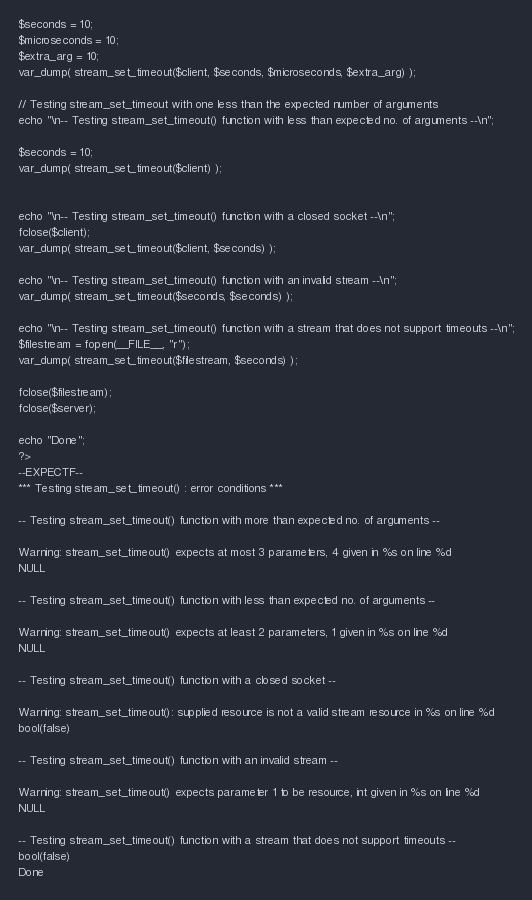<code> <loc_0><loc_0><loc_500><loc_500><_PHP_>
$seconds = 10;
$microseconds = 10;
$extra_arg = 10;
var_dump( stream_set_timeout($client, $seconds, $microseconds, $extra_arg) );

// Testing stream_set_timeout with one less than the expected number of arguments
echo "\n-- Testing stream_set_timeout() function with less than expected no. of arguments --\n";

$seconds = 10;
var_dump( stream_set_timeout($client) );


echo "\n-- Testing stream_set_timeout() function with a closed socket --\n";
fclose($client);
var_dump( stream_set_timeout($client, $seconds) );

echo "\n-- Testing stream_set_timeout() function with an invalid stream --\n";
var_dump( stream_set_timeout($seconds, $seconds) );

echo "\n-- Testing stream_set_timeout() function with a stream that does not support timeouts --\n";
$filestream = fopen(__FILE__, "r");
var_dump( stream_set_timeout($filestream, $seconds) );

fclose($filestream);
fclose($server);

echo "Done";
?>
--EXPECTF--
*** Testing stream_set_timeout() : error conditions ***

-- Testing stream_set_timeout() function with more than expected no. of arguments --

Warning: stream_set_timeout() expects at most 3 parameters, 4 given in %s on line %d
NULL

-- Testing stream_set_timeout() function with less than expected no. of arguments --

Warning: stream_set_timeout() expects at least 2 parameters, 1 given in %s on line %d
NULL

-- Testing stream_set_timeout() function with a closed socket --

Warning: stream_set_timeout(): supplied resource is not a valid stream resource in %s on line %d
bool(false)

-- Testing stream_set_timeout() function with an invalid stream --

Warning: stream_set_timeout() expects parameter 1 to be resource, int given in %s on line %d
NULL

-- Testing stream_set_timeout() function with a stream that does not support timeouts --
bool(false)
Done
</code> 